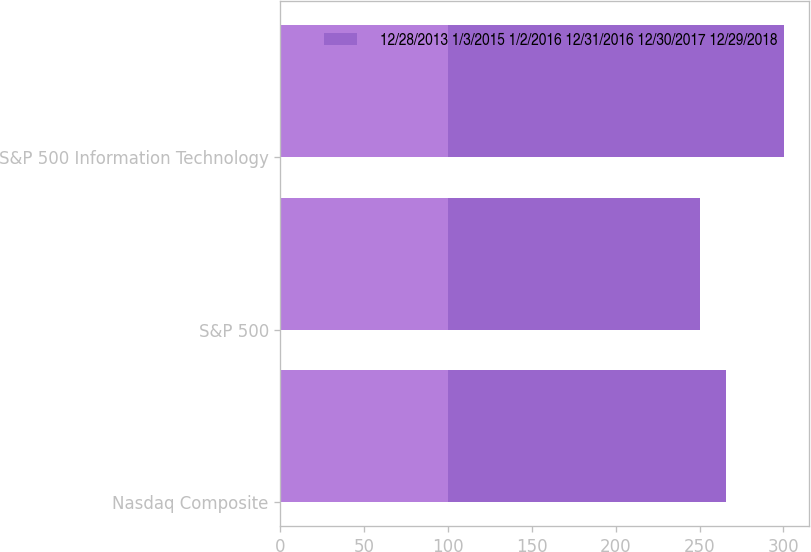Convert chart to OTSL. <chart><loc_0><loc_0><loc_500><loc_500><stacked_bar_chart><ecel><fcel>Nasdaq Composite<fcel>S&P 500<fcel>S&P 500 Information Technology<nl><fcel>nan<fcel>100<fcel>100<fcel>100<nl><fcel>12/28/2013 1/3/2015 1/2/2016 12/31/2016 12/30/2017 12/29/2018<fcel>165.84<fcel>150.33<fcel>200.52<nl></chart> 